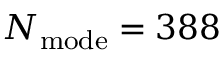<formula> <loc_0><loc_0><loc_500><loc_500>N _ { m o d e } = 3 8 8</formula> 